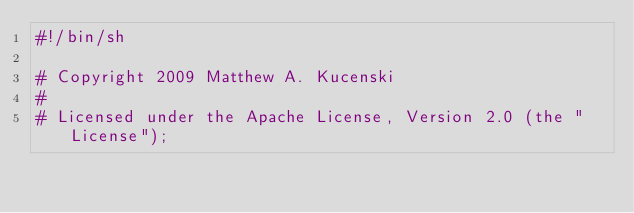Convert code to text. <code><loc_0><loc_0><loc_500><loc_500><_Bash_>#!/bin/sh

# Copyright 2009 Matthew A. Kucenski
#
# Licensed under the Apache License, Version 2.0 (the "License");</code> 